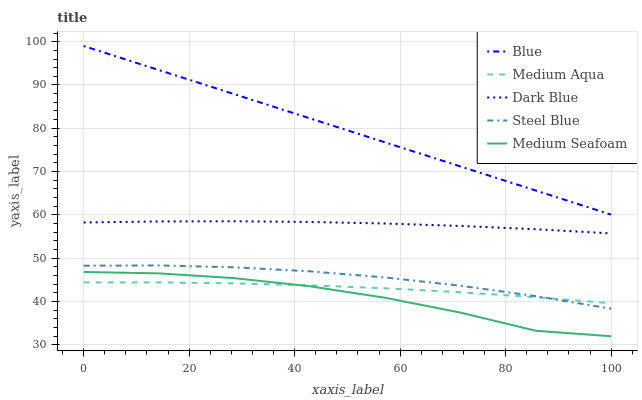Does Medium Seafoam have the minimum area under the curve?
Answer yes or no. Yes. Does Blue have the maximum area under the curve?
Answer yes or no. Yes. Does Dark Blue have the minimum area under the curve?
Answer yes or no. No. Does Dark Blue have the maximum area under the curve?
Answer yes or no. No. Is Blue the smoothest?
Answer yes or no. Yes. Is Medium Seafoam the roughest?
Answer yes or no. Yes. Is Dark Blue the smoothest?
Answer yes or no. No. Is Dark Blue the roughest?
Answer yes or no. No. Does Medium Seafoam have the lowest value?
Answer yes or no. Yes. Does Dark Blue have the lowest value?
Answer yes or no. No. Does Blue have the highest value?
Answer yes or no. Yes. Does Dark Blue have the highest value?
Answer yes or no. No. Is Medium Seafoam less than Blue?
Answer yes or no. Yes. Is Dark Blue greater than Steel Blue?
Answer yes or no. Yes. Does Medium Aqua intersect Medium Seafoam?
Answer yes or no. Yes. Is Medium Aqua less than Medium Seafoam?
Answer yes or no. No. Is Medium Aqua greater than Medium Seafoam?
Answer yes or no. No. Does Medium Seafoam intersect Blue?
Answer yes or no. No. 